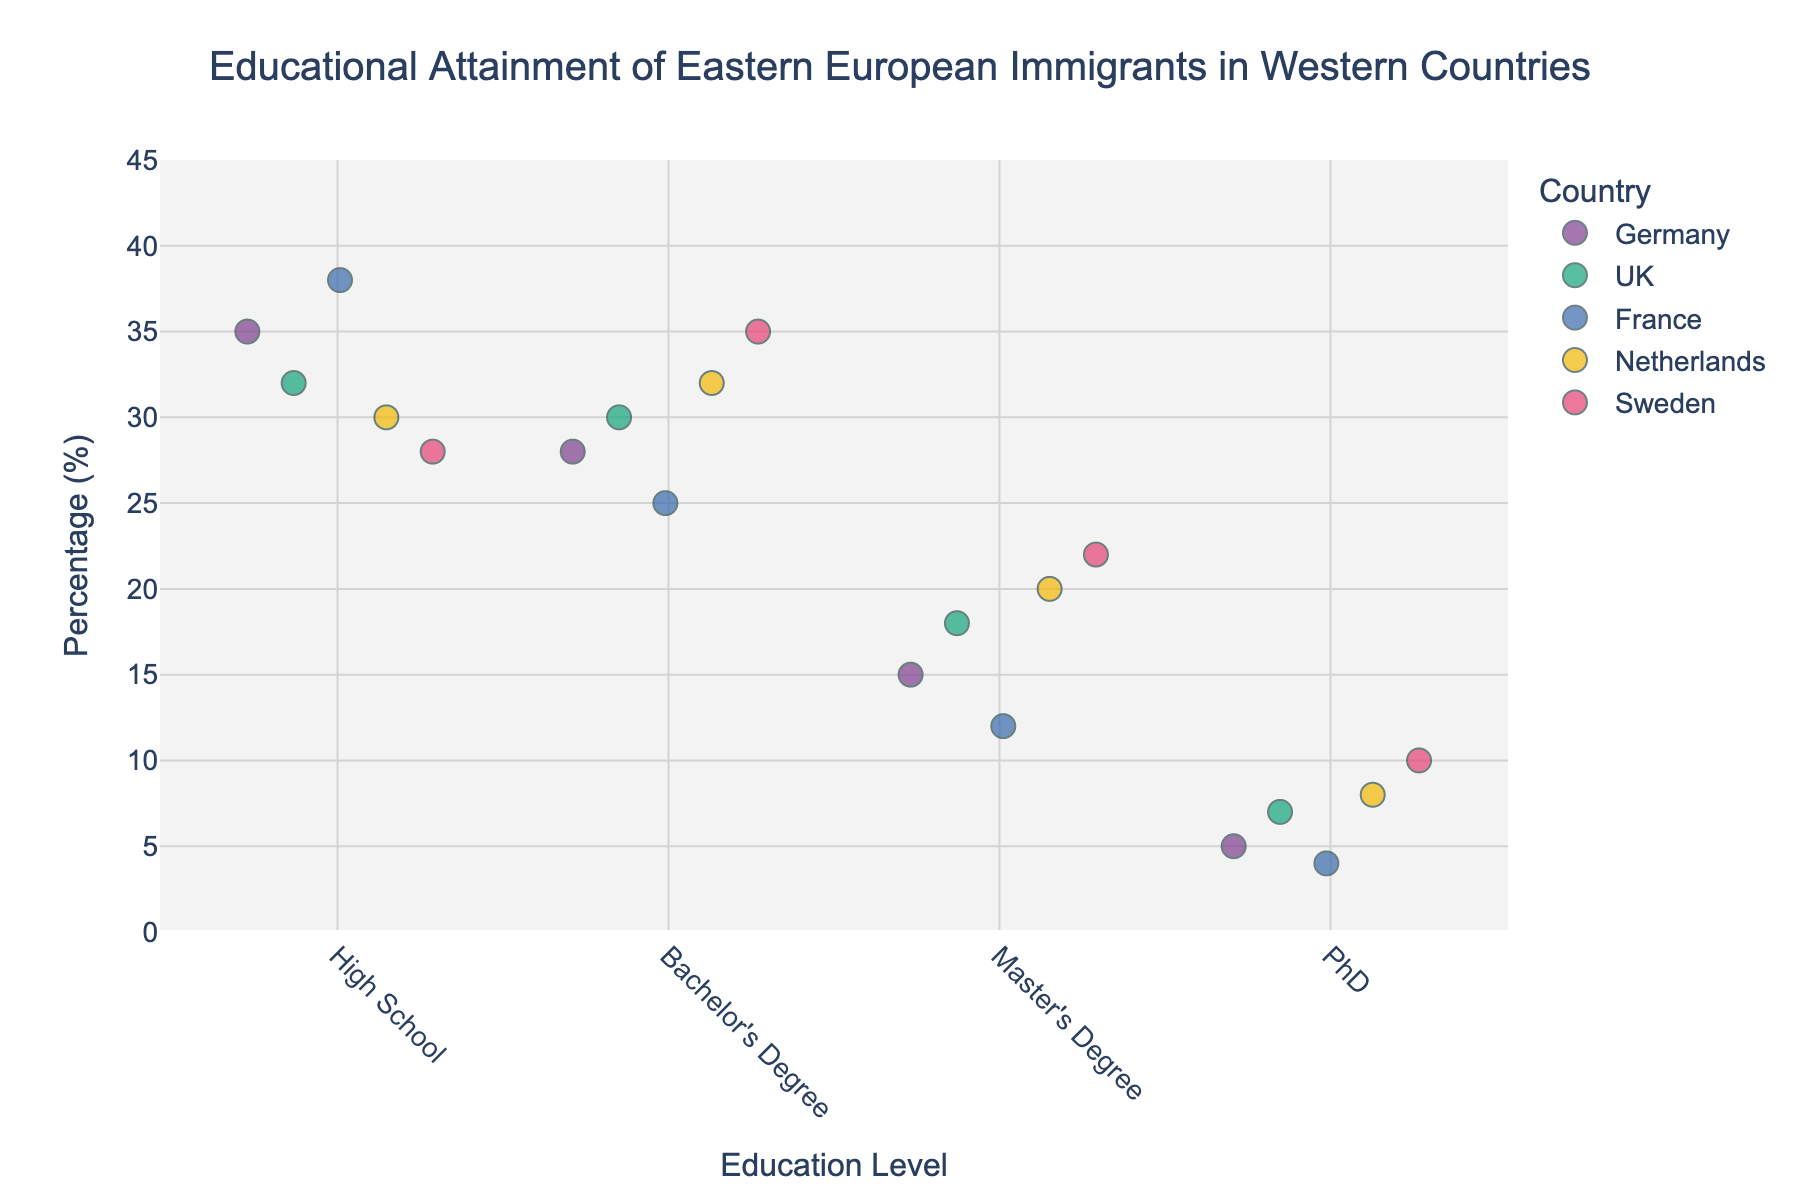What is the most common education level for Eastern European immigrants in the UK? Look at the percentages for each education level for the UK. The highest percentage is for Bachelor's Degree at 30%.
Answer: Bachelor's Degree How many countries have the highest percentage of immigrants with a Master's Degree higher than 15%? Check the Master's Degree percentages for each country, and count the number of countries where this value exceeds 15%. Germany, UK, Netherlands, and Sweden all have Master's Degree percentages above 15%.
Answer: 4 Which country has the highest percentage of immigrants with a PhD? Compare the PhD percentages for each country. Sweden has the highest percentage at 10%.
Answer: Sweden What is the range of percentages for Bachelor's Degree across all countries? The lowest Bachelor's Degree percentage is 25% (France) and the highest is 35% (Sweden), so the range is 35% - 25% = 10%.
Answer: 10% What is the average percentage of immigrants with High School education across the listed countries? Calculate the sum of High School percentages: 35% (Germany) + 32% (UK) + 38% (France) + 30% (Netherlands) + 28% (Sweden) = 163%. Then, divide by the number of countries (5). The average is 163% / 5 = 32.6%.
Answer: 32.6% Which country has the smallest difference in percentages between High School and PhD education levels? Calculate the differences for each country: Germany: 35% - 5% = 30%, UK: 32% - 7% = 25%, France: 38% - 4% = 34%, Netherlands: 30% - 8% = 22%, Sweden: 28% - 10% = 18%. Sweden has the smallest difference of 18%.
Answer: Sweden Is the percentage of immigrants with a PhD higher in the Netherlands or in Germany? Compare the PhD percentages. Netherlands has 8%, while Germany has 5%. 8% is higher than 5%.
Answer: Netherlands What is the total percentage of immigrants with a Bachelor's Degree and Master's Degree in France? Add the Bachelor's Degree and Master's Degree percentages for France: 25% + 12% = 37%.
Answer: 37% Which education level has the widest range of percentages among the countries? Calculate the range for each education level: High School (38% - 28% = 10%), Bachelor's Degree (35% - 25% = 10%), Master's Degree (22% - 12% = 10%), PhD (10% - 4% = 6%). High School, Bachelor's Degree, and Master's Degree all have the widest range at 10%.
Answer: High School, Bachelor's Degree, Master's Degree What is the combined percentage of immigrants with Bachelor's Degrees in Germany and Sweden? Add the Bachelor's Degree percentages for Germany and Sweden: 28% (Germany) + 35% (Sweden) = 63%.
Answer: 63% 